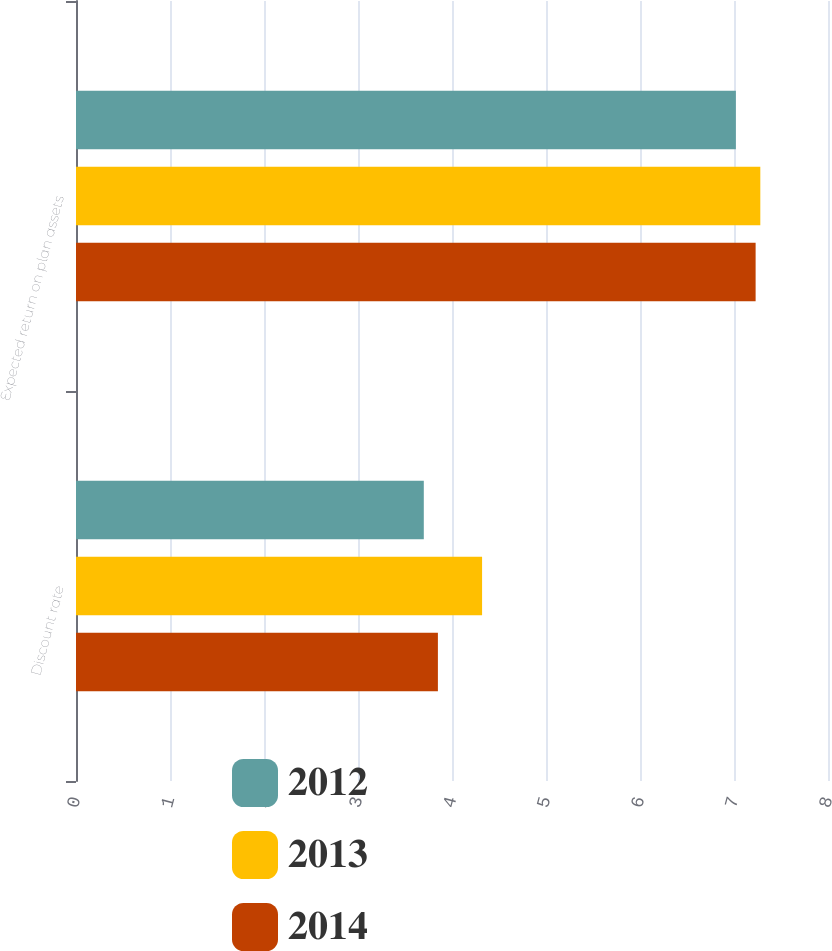Convert chart to OTSL. <chart><loc_0><loc_0><loc_500><loc_500><stacked_bar_chart><ecel><fcel>Discount rate<fcel>Expected return on plan assets<nl><fcel>2012<fcel>3.7<fcel>7.02<nl><fcel>2013<fcel>4.32<fcel>7.28<nl><fcel>2014<fcel>3.85<fcel>7.23<nl></chart> 